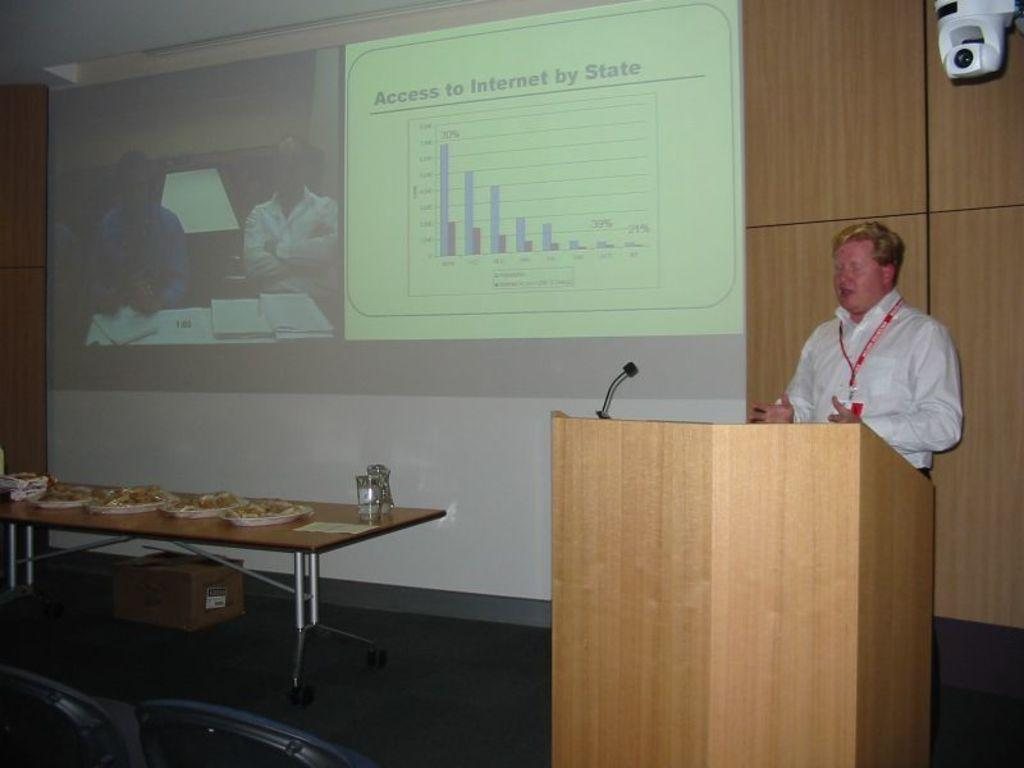What is the man near in the image? The man is standing near a podium in the image. What can be seen in the background of the image? There is a screen, a camera, a table, food, and a glass in the background. What might the man be doing near the podium? The man might be giving a presentation or speech near the podium. How many grains of rice are visible on the man's eye in the image? There are no grains of rice visible on the man's eye in the image. What type of group is present in the image? There is no group present in the image; it features a man standing near a podium with various items in the background. 